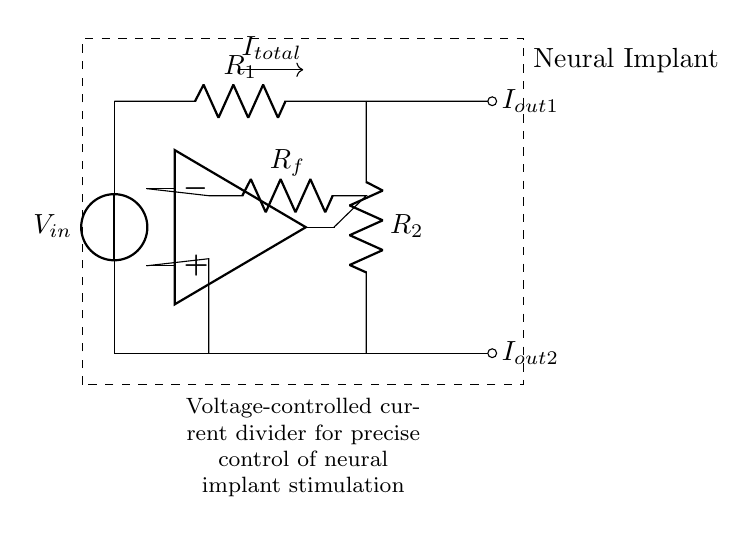What is the total current in this circuit? The total current, denoted as I_total, is indicated by the arrow labeled above the resistor connecting the two branches, but the specific numerical value is not shown in the diagram.
Answer: I_total What is the resistance of R1? The circuit diagram labels R1, but it does not specify a numerical value for its resistance. Therefore, the exact ohmic value cannot be determined from the diagram.
Answer: R1 How is the current divided in this circuit? The current is divided between two resistors R1 and R2 in parallel. The division is determined by the resistance values; more current goes through the path with the lower resistance, following the current divider rule.
Answer: Current divider What role does the operational amplifier play in this circuit? The operational amplifier acts as a feedback control mechanism for the voltage-controlled current divider, allowing for precise regulation of the output currents I_out1 and I_out2 based on the input voltage.
Answer: Feedback control Which component controls the output currents in the neural implant? The operational amplifier controls the output currents by adjusting the feedback loop with resistor R_f, allowing for precise manipulation of the current flowing to the neural implant.
Answer: Operational amplifier What is the connection configuration of R1 and R2? R1 and R2 are connected in a parallel configuration, illustrated by their downward and horizontal connections to the common ground. This configuration allows for a current divider effect based on their resistance values.
Answer: Parallel How does the voltage source affect circuit operation? The voltage source V_in provides the potential difference necessary for current flow through the circuit, influencing the output current distribution across R1 and R2, which is crucial for stimulation control in the neural implant.
Answer: Potential difference 